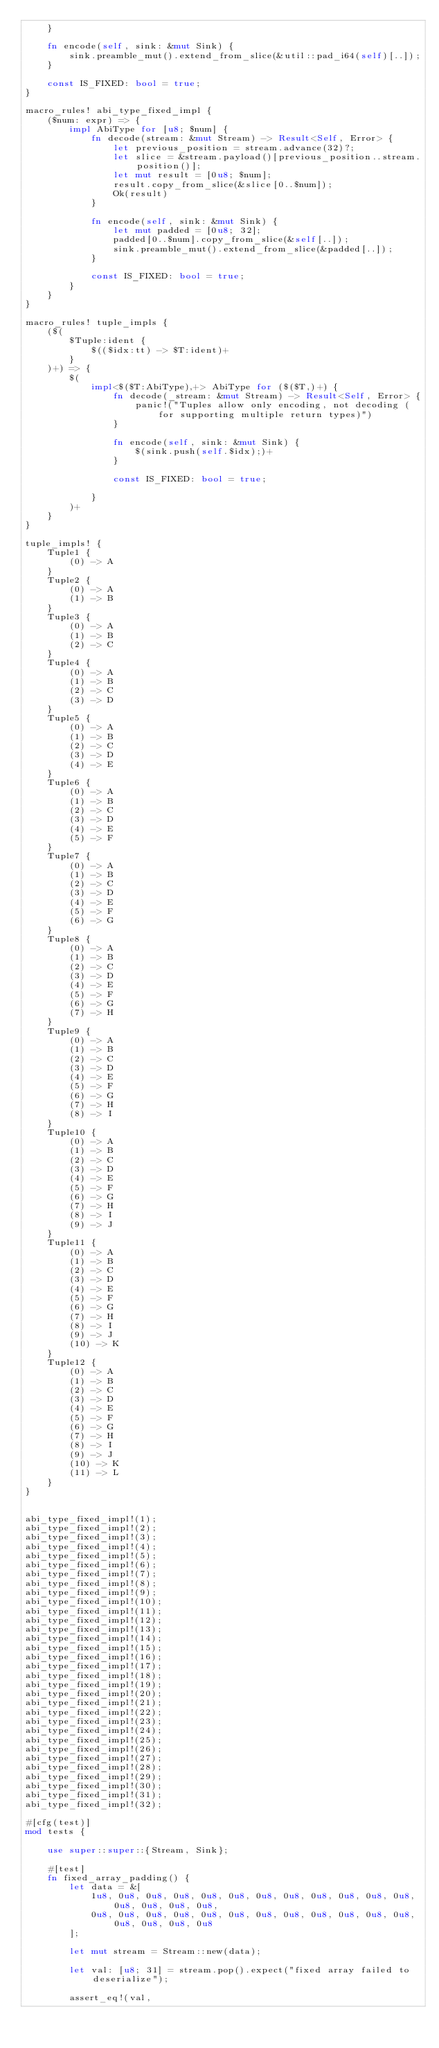Convert code to text. <code><loc_0><loc_0><loc_500><loc_500><_Rust_>	}

	fn encode(self, sink: &mut Sink) {
		sink.preamble_mut().extend_from_slice(&util::pad_i64(self)[..]);
	}

	const IS_FIXED: bool = true;
}

macro_rules! abi_type_fixed_impl {
	($num: expr) => {
		impl AbiType for [u8; $num] {
			fn decode(stream: &mut Stream) -> Result<Self, Error> {
				let previous_position = stream.advance(32)?;
				let slice = &stream.payload()[previous_position..stream.position()];
				let mut result = [0u8; $num];
				result.copy_from_slice(&slice[0..$num]);
				Ok(result)
			}

			fn encode(self, sink: &mut Sink) {
				let mut padded = [0u8; 32];
				padded[0..$num].copy_from_slice(&self[..]);
				sink.preamble_mut().extend_from_slice(&padded[..]);
			}

			const IS_FIXED: bool = true;
		}
	}
}

macro_rules! tuple_impls {
	($(
		$Tuple:ident {
			$(($idx:tt) -> $T:ident)+
		}
	)+) => {
		$(
			impl<$($T:AbiType),+> AbiType for ($($T,)+) {
				fn decode(_stream: &mut Stream) -> Result<Self, Error> {
					panic!("Tuples allow only encoding, not decoding (for supporting multiple return types)")
				}

				fn encode(self, sink: &mut Sink) {
					$(sink.push(self.$idx);)+
				}

				const IS_FIXED: bool = true;

			}
		)+
	}
}

tuple_impls! {
	Tuple1 {
		(0) -> A
	}
	Tuple2 {
		(0) -> A
		(1) -> B
	}
	Tuple3 {
		(0) -> A
		(1) -> B
		(2) -> C
	}
	Tuple4 {
		(0) -> A
		(1) -> B
		(2) -> C
		(3) -> D
	}
	Tuple5 {
		(0) -> A
		(1) -> B
		(2) -> C
		(3) -> D
		(4) -> E
	}
	Tuple6 {
		(0) -> A
		(1) -> B
		(2) -> C
		(3) -> D
		(4) -> E
		(5) -> F
	}
	Tuple7 {
		(0) -> A
		(1) -> B
		(2) -> C
		(3) -> D
		(4) -> E
		(5) -> F
		(6) -> G
	}
	Tuple8 {
		(0) -> A
		(1) -> B
		(2) -> C
		(3) -> D
		(4) -> E
		(5) -> F
		(6) -> G
		(7) -> H
	}
	Tuple9 {
		(0) -> A
		(1) -> B
		(2) -> C
		(3) -> D
		(4) -> E
		(5) -> F
		(6) -> G
		(7) -> H
		(8) -> I
	}
	Tuple10 {
		(0) -> A
		(1) -> B
		(2) -> C
		(3) -> D
		(4) -> E
		(5) -> F
		(6) -> G
		(7) -> H
		(8) -> I
		(9) -> J
	}
	Tuple11 {
		(0) -> A
		(1) -> B
		(2) -> C
		(3) -> D
		(4) -> E
		(5) -> F
		(6) -> G
		(7) -> H
		(8) -> I
		(9) -> J
		(10) -> K
	}
	Tuple12 {
		(0) -> A
		(1) -> B
		(2) -> C
		(3) -> D
		(4) -> E
		(5) -> F
		(6) -> G
		(7) -> H
		(8) -> I
		(9) -> J
		(10) -> K
		(11) -> L
	}
}


abi_type_fixed_impl!(1);
abi_type_fixed_impl!(2);
abi_type_fixed_impl!(3);
abi_type_fixed_impl!(4);
abi_type_fixed_impl!(5);
abi_type_fixed_impl!(6);
abi_type_fixed_impl!(7);
abi_type_fixed_impl!(8);
abi_type_fixed_impl!(9);
abi_type_fixed_impl!(10);
abi_type_fixed_impl!(11);
abi_type_fixed_impl!(12);
abi_type_fixed_impl!(13);
abi_type_fixed_impl!(14);
abi_type_fixed_impl!(15);
abi_type_fixed_impl!(16);
abi_type_fixed_impl!(17);
abi_type_fixed_impl!(18);
abi_type_fixed_impl!(19);
abi_type_fixed_impl!(20);
abi_type_fixed_impl!(21);
abi_type_fixed_impl!(22);
abi_type_fixed_impl!(23);
abi_type_fixed_impl!(24);
abi_type_fixed_impl!(25);
abi_type_fixed_impl!(26);
abi_type_fixed_impl!(27);
abi_type_fixed_impl!(28);
abi_type_fixed_impl!(29);
abi_type_fixed_impl!(30);
abi_type_fixed_impl!(31);
abi_type_fixed_impl!(32);

#[cfg(test)]
mod tests {

	use super::super::{Stream, Sink};

	#[test]
	fn fixed_array_padding() {
		let data = &[
			1u8, 0u8, 0u8, 0u8, 0u8, 0u8, 0u8, 0u8, 0u8, 0u8, 0u8, 0u8, 0u8, 0u8, 0u8, 0u8,
			0u8, 0u8, 0u8, 0u8, 0u8, 0u8, 0u8, 0u8, 0u8, 0u8, 0u8, 0u8, 0u8, 0u8, 0u8, 0u8
		];

		let mut stream = Stream::new(data);

		let val: [u8; 31] = stream.pop().expect("fixed array failed to deserialize");

		assert_eq!(val,</code> 